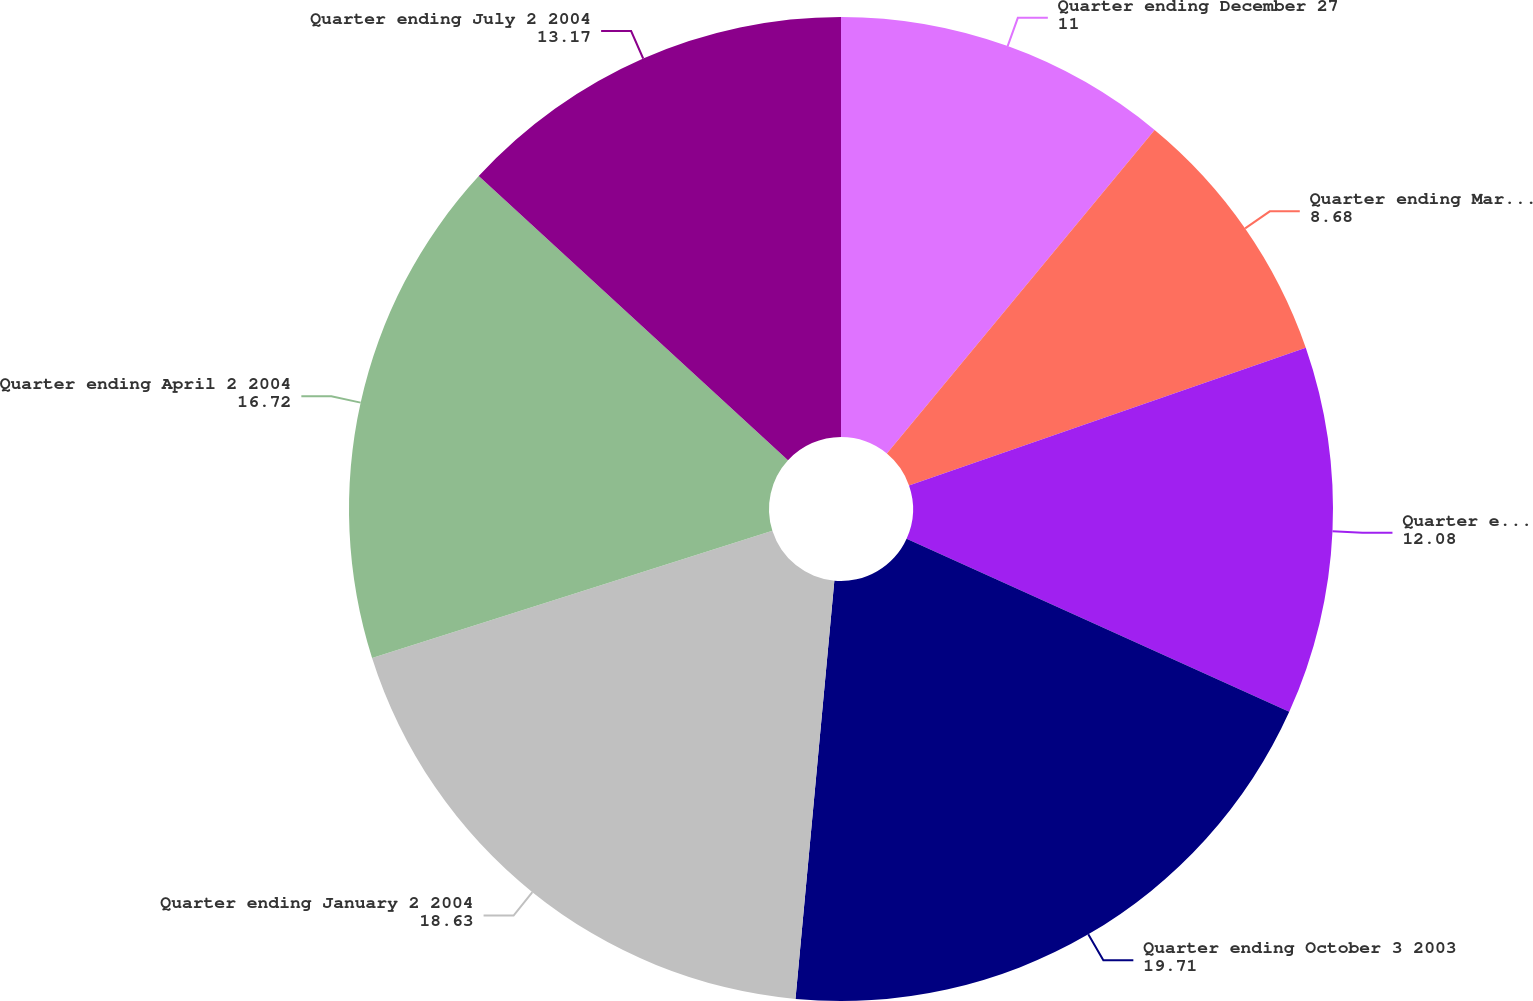<chart> <loc_0><loc_0><loc_500><loc_500><pie_chart><fcel>Quarter ending December 27<fcel>Quarter ending March 28 2003<fcel>Quarter ending June 27 2003<fcel>Quarter ending October 3 2003<fcel>Quarter ending January 2 2004<fcel>Quarter ending April 2 2004<fcel>Quarter ending July 2 2004<nl><fcel>11.0%<fcel>8.68%<fcel>12.08%<fcel>19.71%<fcel>18.63%<fcel>16.72%<fcel>13.17%<nl></chart> 